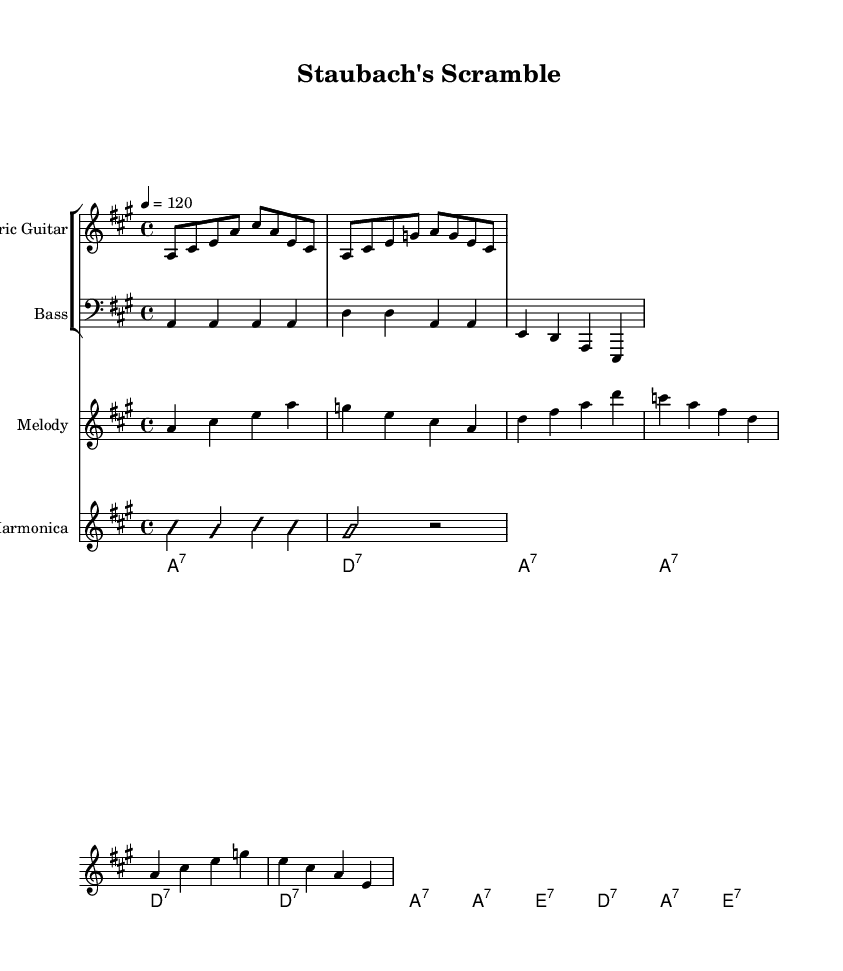What is the key signature of this music? The key signature is A major, which has three sharps (F#, C#, and G#). We can identify the key signature by looking at the opening of the score where the sharps are indicated.
Answer: A major What is the time signature of this sheet music? The time signature is 4/4, meaning there are four beats per measure and each quarter note receives one beat. This is indicated at the beginning of the piece.
Answer: 4/4 What is the tempo marking for this music? The tempo marking is 120, denoting a moderately fast pace where each quarter note is played at 120 beats per minute. It is indicated at the start of the score.
Answer: 120 Which instrument plays the melody in this piece? The melody is played by the staff labeled "Melody," which is usually designated for instruments such as vocals or solo instruments. In this particular score, it is notated for a treble clef instrument, specifically assigning it to the melody with lyrics.
Answer: Melody How many measures are in the harmonic structure? The harmonic structure contains a total of three measures, which can be determined by counting the chord symbols (A7, D7, E7) that appear in the designated chord section, each corresponding to a measure.
Answer: Three What style of music does this piece represent? This piece represents Electric Blues, a genre characterized by the use of electric instruments and blues chord progressions, which is evident from the style of play and instrumentation, particularly the electric guitar and harmonica solos used here.
Answer: Electric Blues Who is the player referenced in the lyrics? The player referenced in the lyrics is Roger Staubach, a legendary quarterback for the Dallas Cowboys, indicating the thematic connection to football through his notable play style and contributions to the team.
Answer: Roger Staubach 